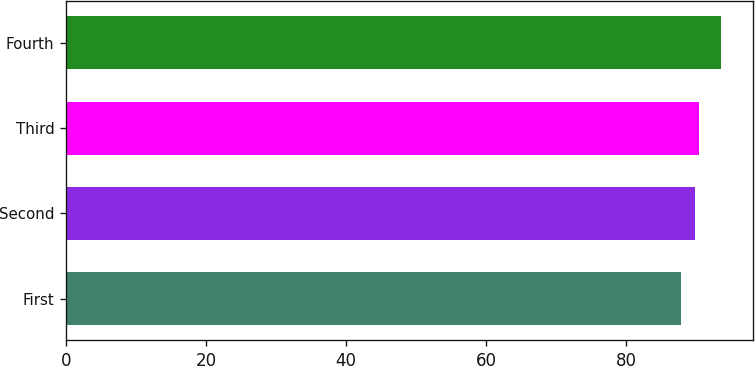<chart> <loc_0><loc_0><loc_500><loc_500><bar_chart><fcel>First<fcel>Second<fcel>Third<fcel>Fourth<nl><fcel>87.8<fcel>89.85<fcel>90.41<fcel>93.45<nl></chart> 